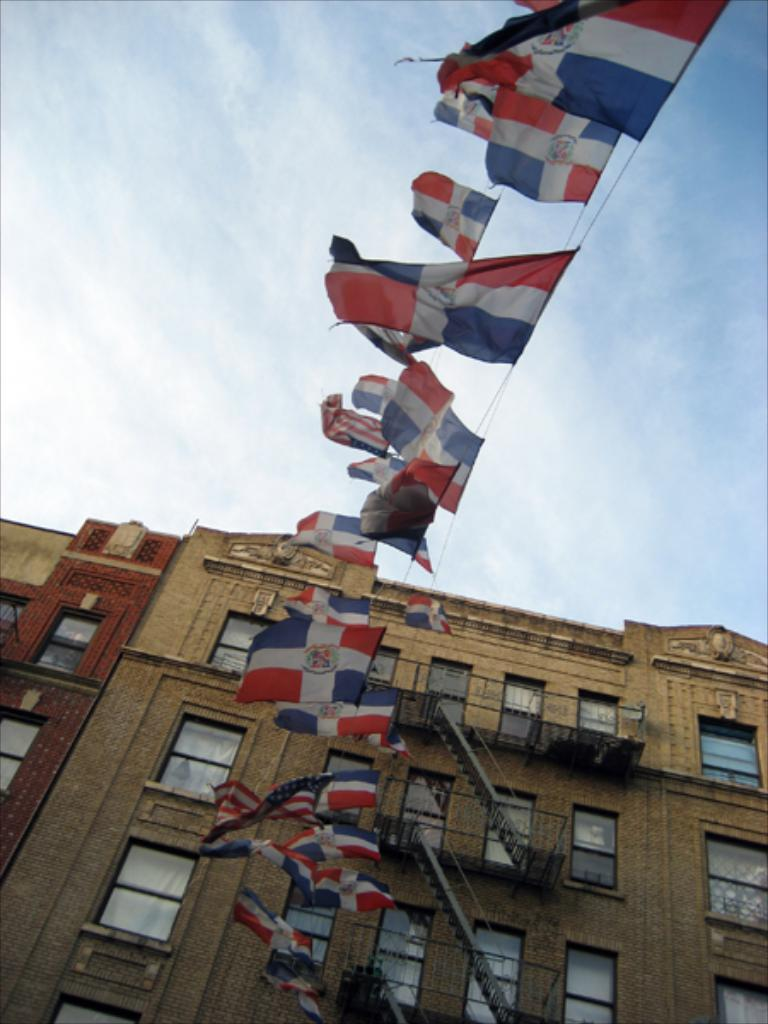What can be seen hanging from the ropes in the image? There are flags hanging from the ropes in the image. What type of structure is visible in the image? There is a building with windows in the image. What architectural feature is present in the building? The building has staircases. What is visible in the background of the image? The sky is visible behind the building. Can you tell me how many geese are flying in the image? There are no geese present in the image; it features ropes with flags, a building with windows and staircases, and a visible sky. How can the scissors be used to join the flags together in the image? There are no scissors present in the image, and the flags are already attached to the ropes. 